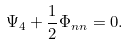Convert formula to latex. <formula><loc_0><loc_0><loc_500><loc_500>\Psi _ { 4 } + \frac { 1 } { 2 } \Phi _ { n n } = 0 .</formula> 